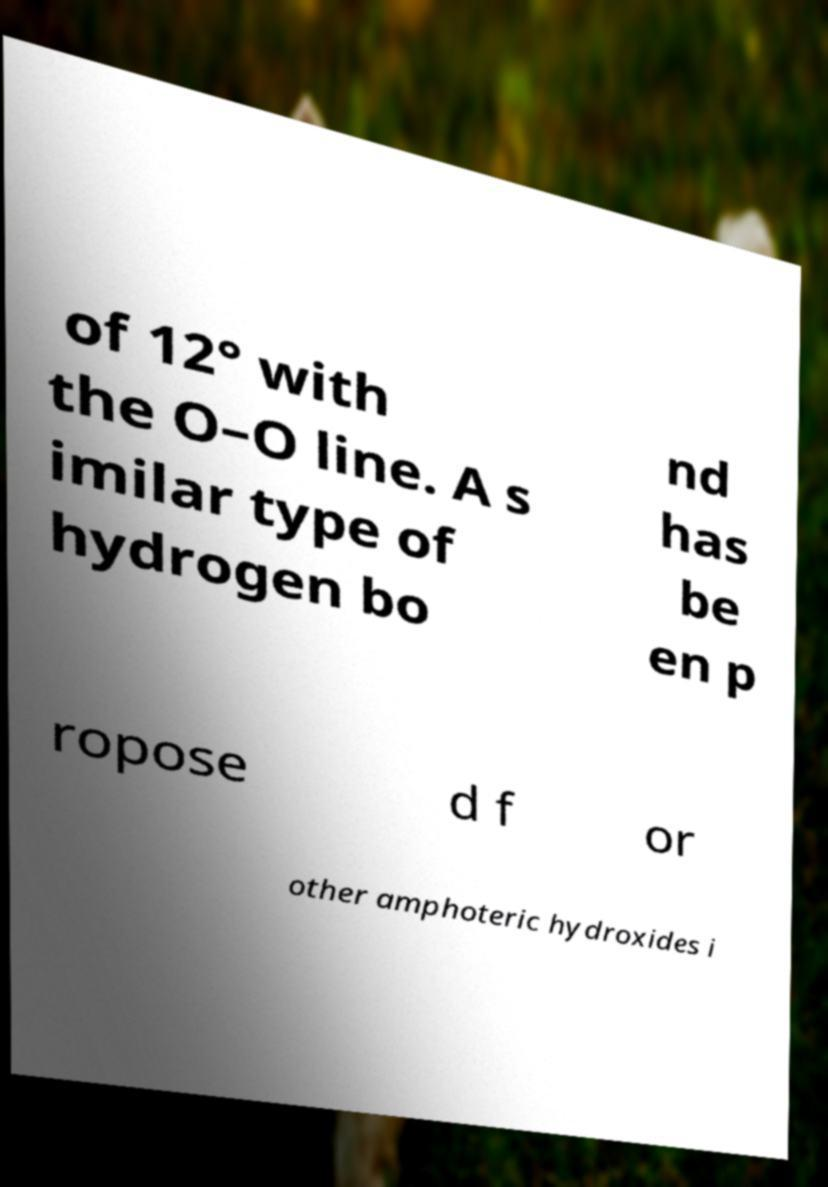Please read and relay the text visible in this image. What does it say? of 12° with the O–O line. A s imilar type of hydrogen bo nd has be en p ropose d f or other amphoteric hydroxides i 